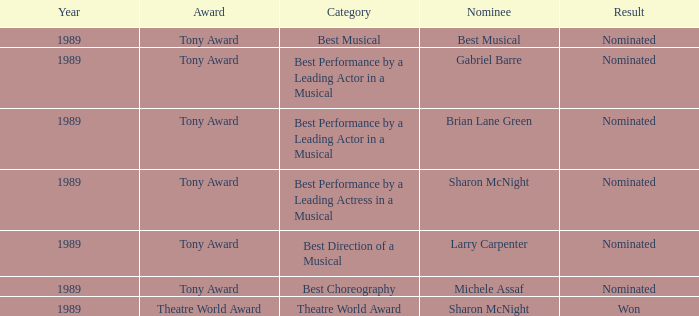What was the candidate for best musical? Best Musical. 